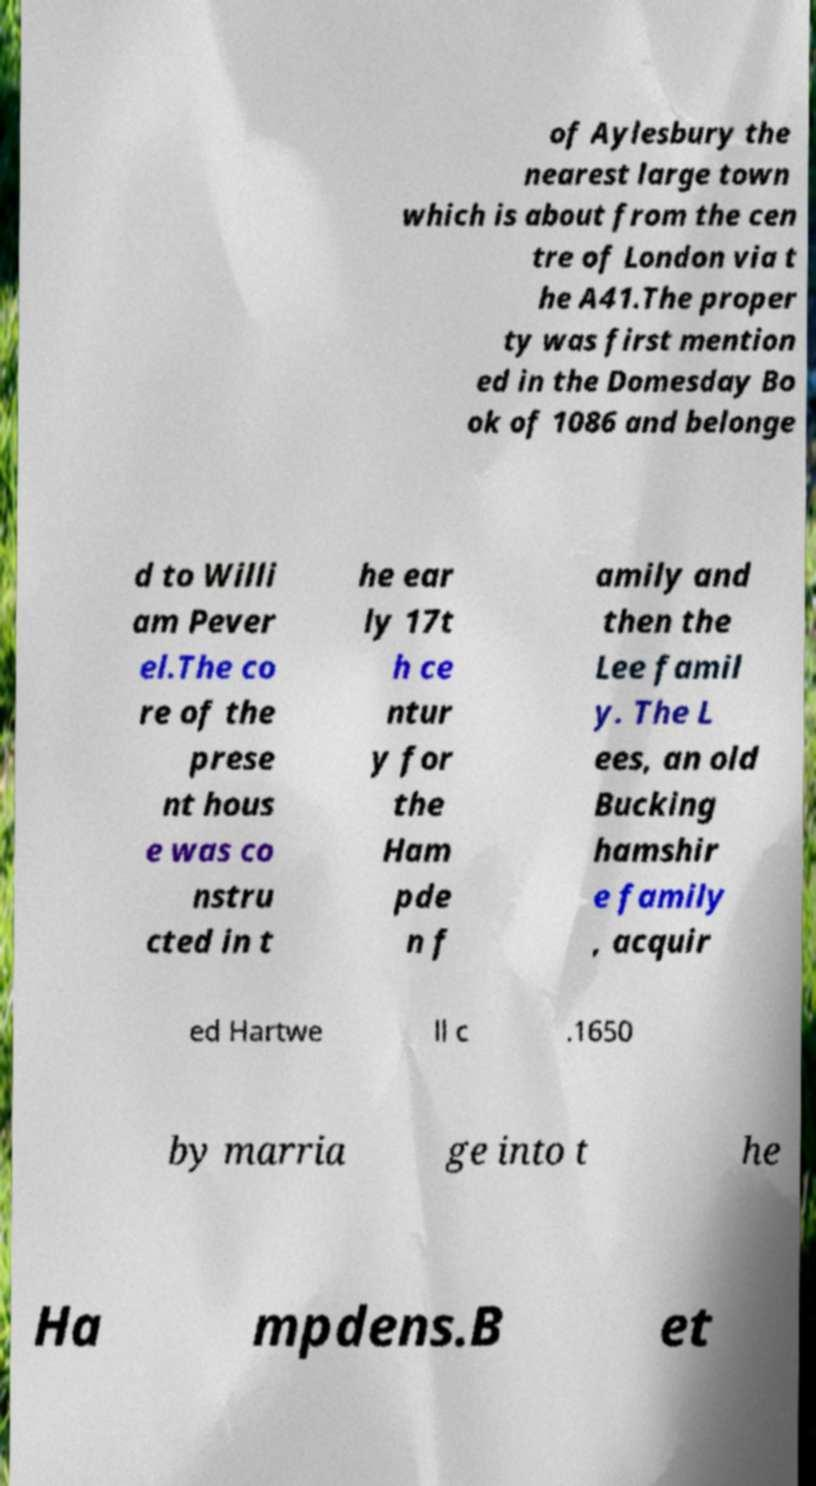Could you assist in decoding the text presented in this image and type it out clearly? of Aylesbury the nearest large town which is about from the cen tre of London via t he A41.The proper ty was first mention ed in the Domesday Bo ok of 1086 and belonge d to Willi am Pever el.The co re of the prese nt hous e was co nstru cted in t he ear ly 17t h ce ntur y for the Ham pde n f amily and then the Lee famil y. The L ees, an old Bucking hamshir e family , acquir ed Hartwe ll c .1650 by marria ge into t he Ha mpdens.B et 